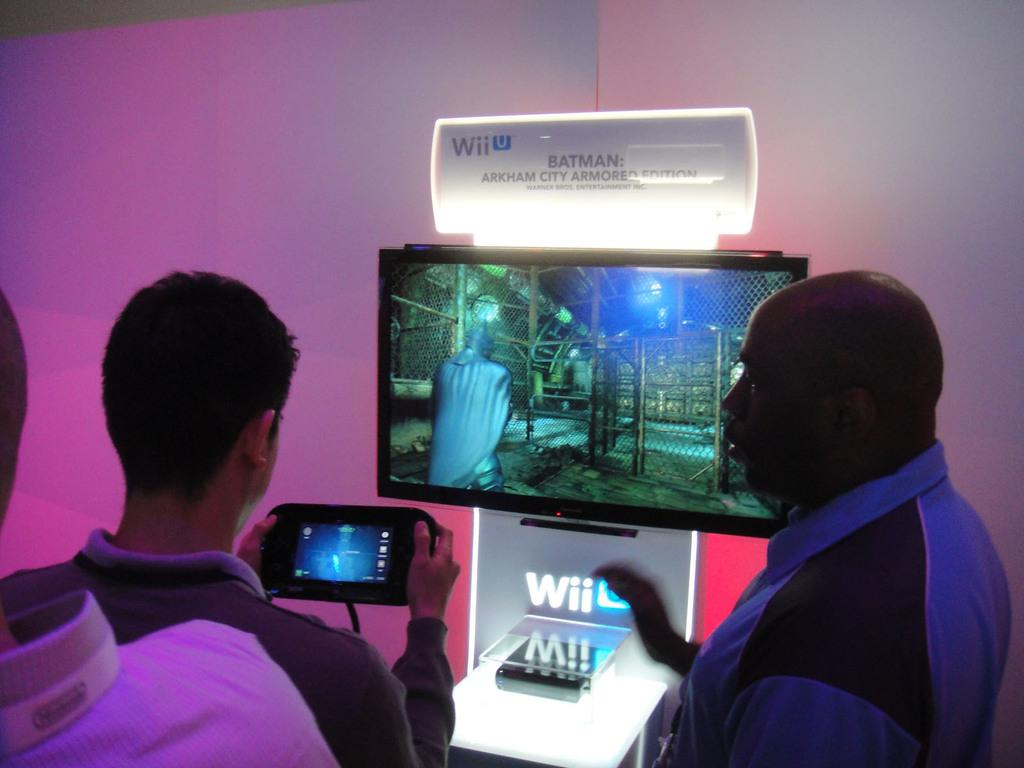Provide a one-sentence caption for the provided image. A man plays Batman: Arkham City Armored Edition on a Wii display. 